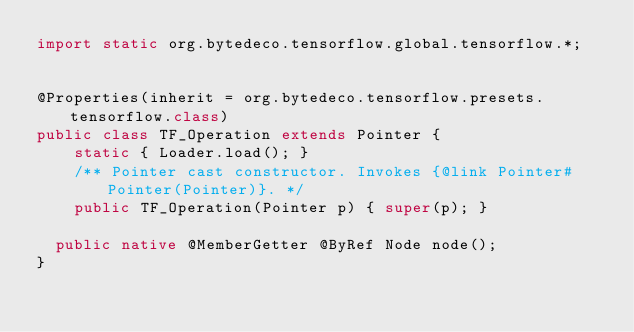Convert code to text. <code><loc_0><loc_0><loc_500><loc_500><_Java_>import static org.bytedeco.tensorflow.global.tensorflow.*;


@Properties(inherit = org.bytedeco.tensorflow.presets.tensorflow.class)
public class TF_Operation extends Pointer {
    static { Loader.load(); }
    /** Pointer cast constructor. Invokes {@link Pointer#Pointer(Pointer)}. */
    public TF_Operation(Pointer p) { super(p); }

  public native @MemberGetter @ByRef Node node();
}
</code> 